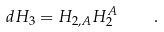<formula> <loc_0><loc_0><loc_500><loc_500>d H _ { 3 } = H _ { 2 , A } H _ { 2 } ^ { A } \quad .</formula> 